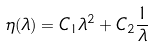Convert formula to latex. <formula><loc_0><loc_0><loc_500><loc_500>\eta ( \lambda ) = C _ { 1 } \lambda ^ { 2 } + C _ { 2 } \frac { 1 } { \lambda }</formula> 